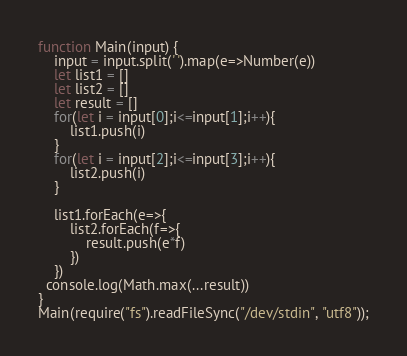<code> <loc_0><loc_0><loc_500><loc_500><_JavaScript_>function Main(input) {
	input = input.split(' ').map(e=>Number(e))
  	let list1 = []
    let list2 = []
    let result = []
    for(let i = input[0];i<=input[1];i++){
    	list1.push(i)
    }
	for(let i = input[2];i<=input[3];i++){
    	list2.push(i)
    }
  	
  	list1.forEach(e=>{
    	list2.forEach(f=>{
        	result.push(e*f)
        })
    })
  console.log(Math.max(...result))
}
Main(require("fs").readFileSync("/dev/stdin", "utf8"));</code> 